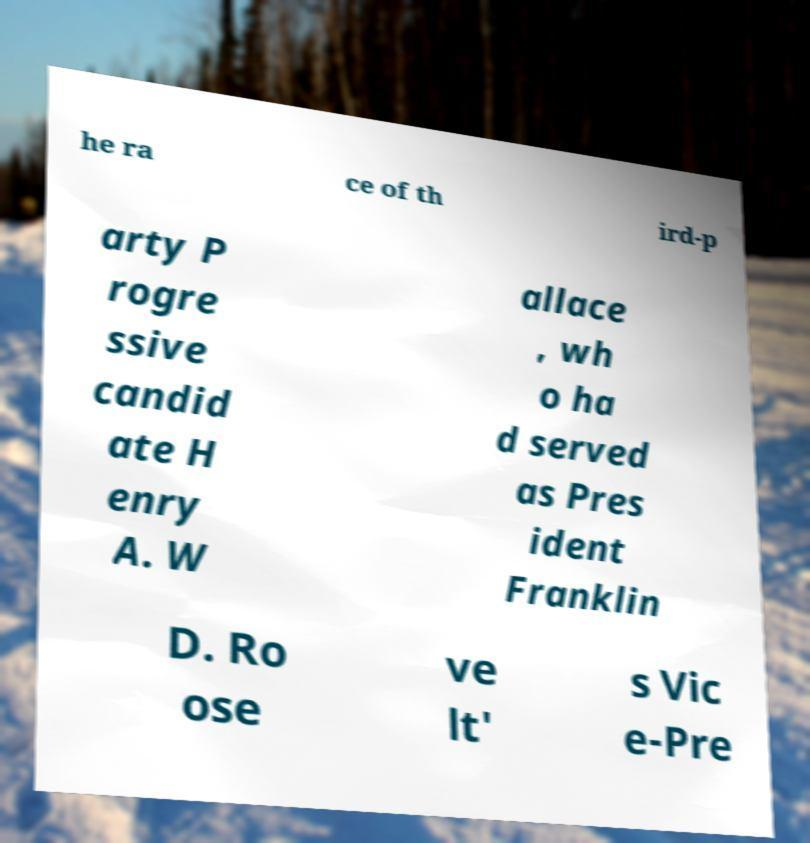For documentation purposes, I need the text within this image transcribed. Could you provide that? he ra ce of th ird-p arty P rogre ssive candid ate H enry A. W allace , wh o ha d served as Pres ident Franklin D. Ro ose ve lt' s Vic e-Pre 